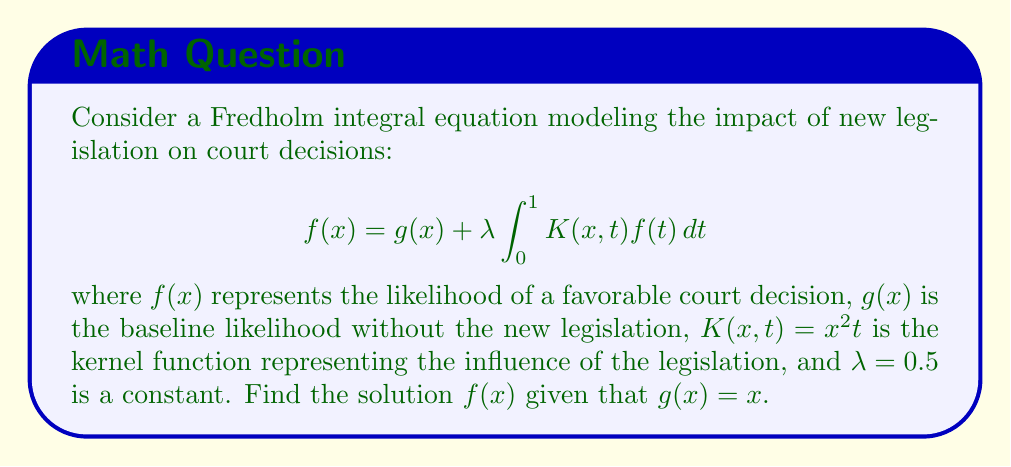Teach me how to tackle this problem. To solve this Fredholm integral equation, we'll follow these steps:

1) First, let's assume a solution of the form $f(x) = ax + b$, where $a$ and $b$ are constants to be determined.

2) Substitute this into the integral equation:

   $ax + b = x + 0.5 \int_0^1 x^2t(at + b)dt$

3) Evaluate the integral:

   $ax + b = x + 0.5x^2 \int_0^1 (at^2 + bt)dt$
   
   $= x + 0.5x^2 (\frac{a}{3} + \frac{b}{2})$

4) Equate coefficients of $x$ and constant terms:

   For $x$: $a = 1$
   
   For constant terms: $b = 0.5(\frac{a}{3} + \frac{b}{2})$

5) From the first equation, we know $a = 1$. Substitute this into the second equation:

   $b = 0.5(\frac{1}{3} + \frac{b}{2})$
   
   $b = \frac{1}{6} + \frac{b}{4}$
   
   $\frac{3b}{4} = \frac{1}{6}$
   
   $b = \frac{2}{9}$

6) Therefore, the solution is:

   $f(x) = x + \frac{2}{9}$

This solution represents the likelihood of a favorable court decision as a function of $x$, which could represent factors like the strength of the case or the judge's predisposition.
Answer: $f(x) = x + \frac{2}{9}$ 